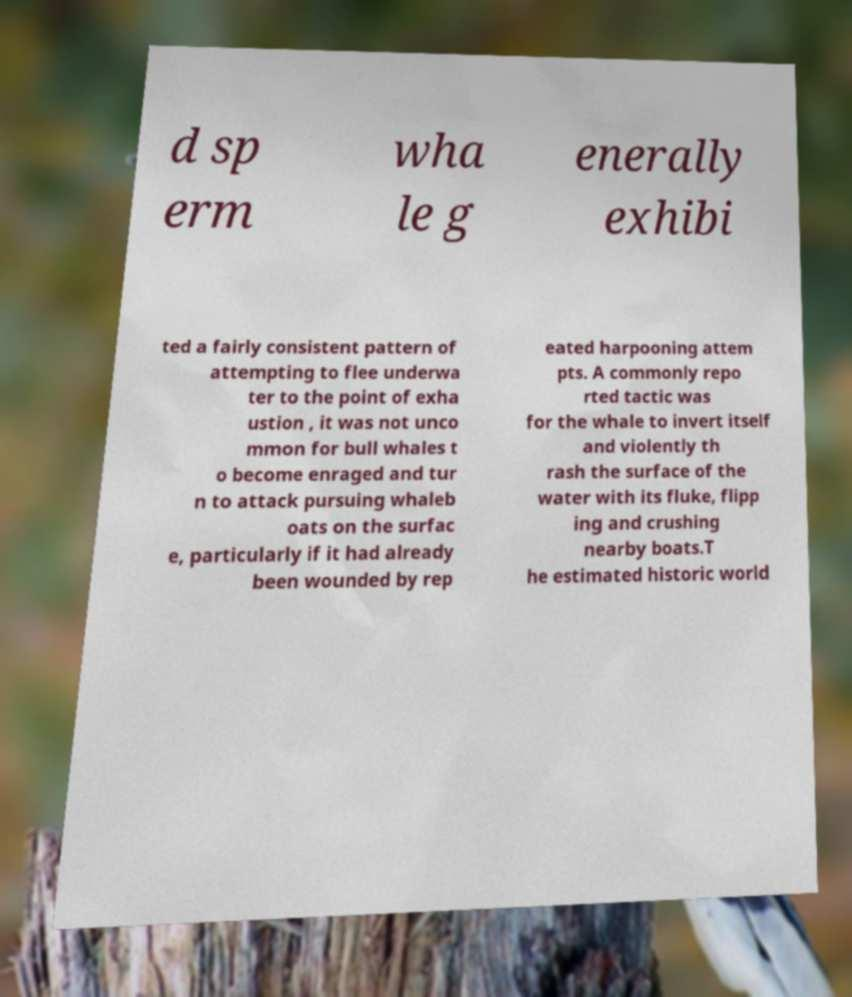I need the written content from this picture converted into text. Can you do that? d sp erm wha le g enerally exhibi ted a fairly consistent pattern of attempting to flee underwa ter to the point of exha ustion , it was not unco mmon for bull whales t o become enraged and tur n to attack pursuing whaleb oats on the surfac e, particularly if it had already been wounded by rep eated harpooning attem pts. A commonly repo rted tactic was for the whale to invert itself and violently th rash the surface of the water with its fluke, flipp ing and crushing nearby boats.T he estimated historic world 